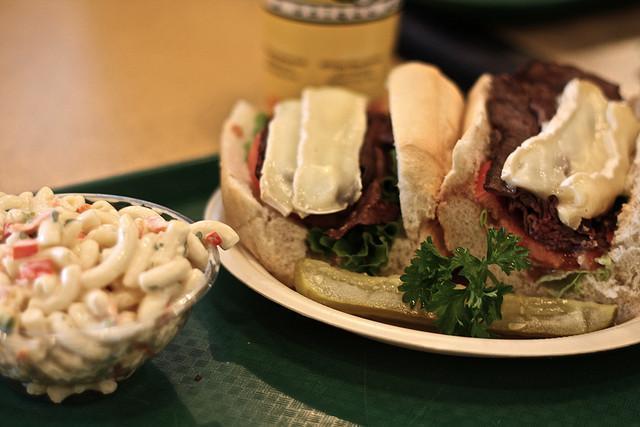What kind of pasta is on the left?
Choose the correct response, then elucidate: 'Answer: answer
Rationale: rationale.'
Options: Bowtie, macaroni, spaghetti, penne. Answer: macaroni.
Rationale: The pasta is macaroni. 